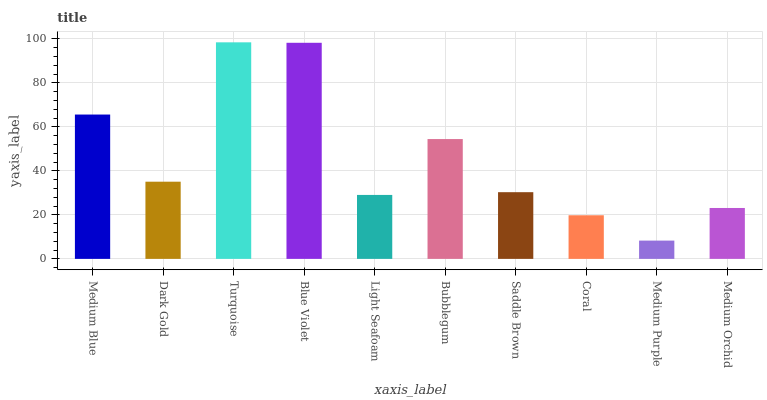Is Medium Purple the minimum?
Answer yes or no. Yes. Is Turquoise the maximum?
Answer yes or no. Yes. Is Dark Gold the minimum?
Answer yes or no. No. Is Dark Gold the maximum?
Answer yes or no. No. Is Medium Blue greater than Dark Gold?
Answer yes or no. Yes. Is Dark Gold less than Medium Blue?
Answer yes or no. Yes. Is Dark Gold greater than Medium Blue?
Answer yes or no. No. Is Medium Blue less than Dark Gold?
Answer yes or no. No. Is Dark Gold the high median?
Answer yes or no. Yes. Is Saddle Brown the low median?
Answer yes or no. Yes. Is Medium Blue the high median?
Answer yes or no. No. Is Dark Gold the low median?
Answer yes or no. No. 